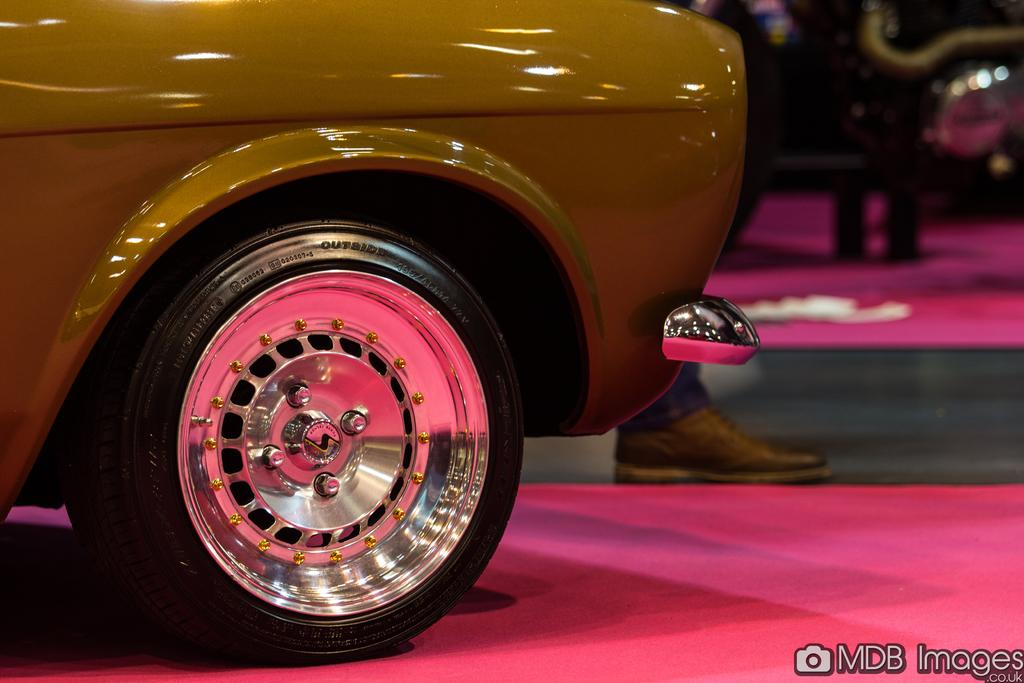What is the main subject in the image? There is a vehicle in the image. Can you describe any details about the vehicle? Unfortunately, the background of the image is blurred, so it's difficult to provide specific details about the vehicle. Are there any human elements in the image? Yes, a human leg wearing a black shoe is visible in the image. What type of kite is being designed by the person in the image? There is no kite present in the image. 